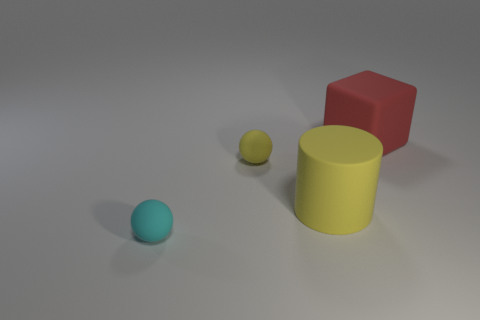Add 2 green matte cubes. How many objects exist? 6 Subtract all blocks. How many objects are left? 3 Subtract all tiny rubber things. Subtract all tiny brown metal things. How many objects are left? 2 Add 1 tiny yellow rubber spheres. How many tiny yellow rubber spheres are left? 2 Add 2 big yellow rubber cylinders. How many big yellow rubber cylinders exist? 3 Subtract 0 yellow cubes. How many objects are left? 4 